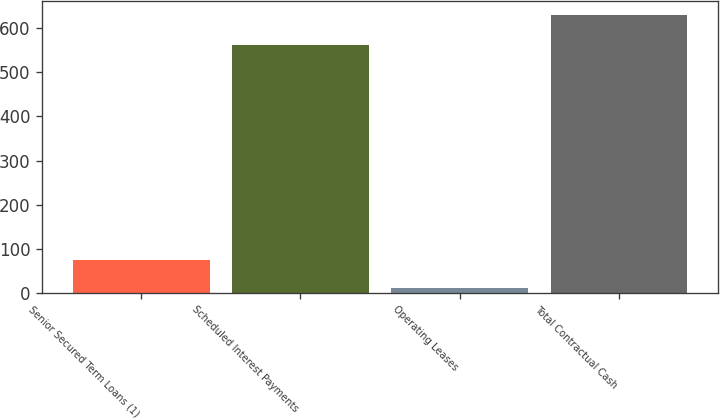<chart> <loc_0><loc_0><loc_500><loc_500><bar_chart><fcel>Senior Secured Term Loans (1)<fcel>Scheduled Interest Payments<fcel>Operating Leases<fcel>Total Contractual Cash<nl><fcel>73.55<fcel>563.2<fcel>11.6<fcel>631.1<nl></chart> 